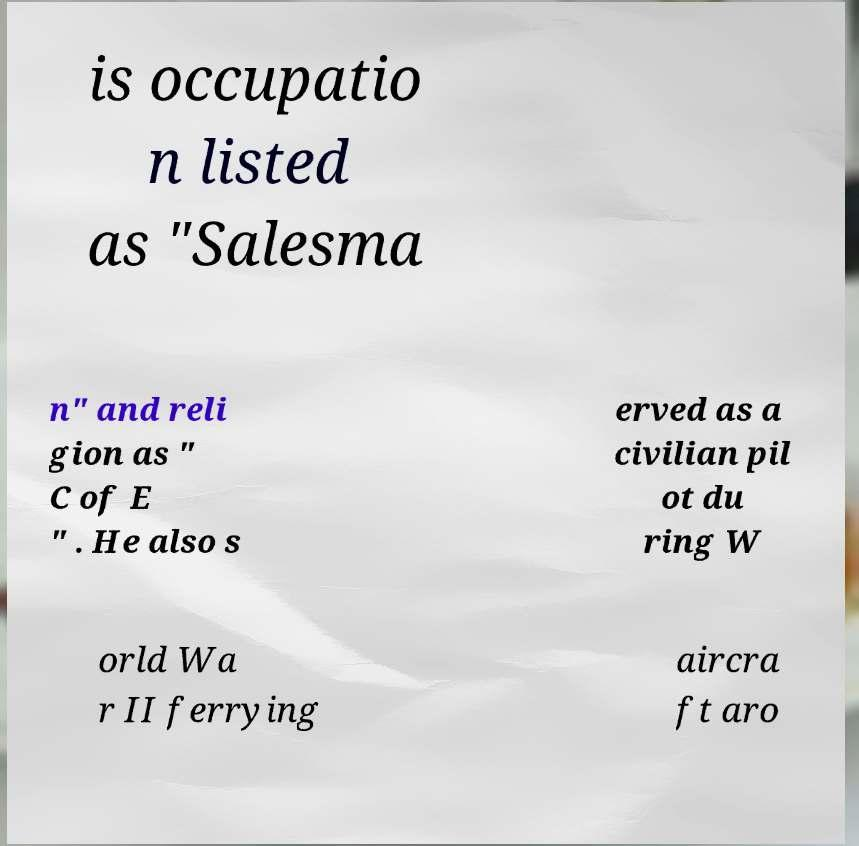Please read and relay the text visible in this image. What does it say? is occupatio n listed as "Salesma n" and reli gion as " C of E " . He also s erved as a civilian pil ot du ring W orld Wa r II ferrying aircra ft aro 